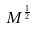Convert formula to latex. <formula><loc_0><loc_0><loc_500><loc_500>M ^ { \frac { 1 } { 2 } }</formula> 